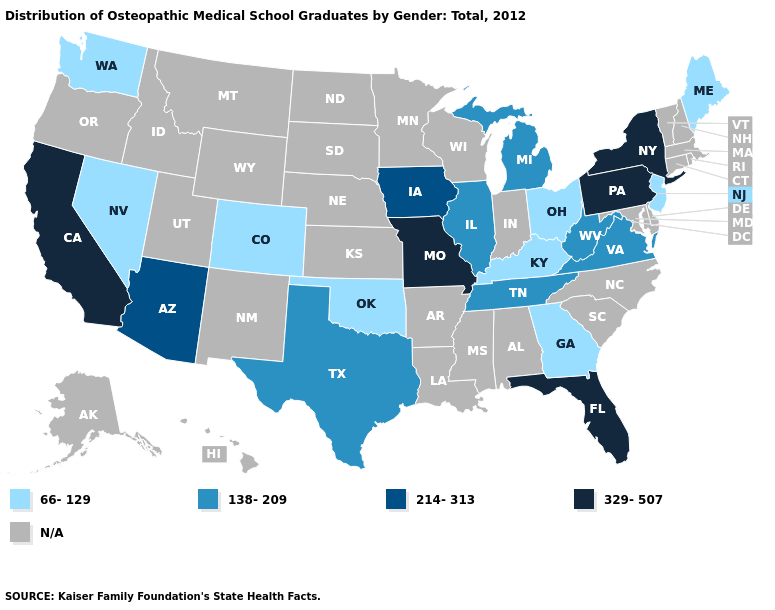What is the lowest value in the MidWest?
Be succinct. 66-129. What is the value of Mississippi?
Be succinct. N/A. Name the states that have a value in the range 214-313?
Keep it brief. Arizona, Iowa. What is the lowest value in the South?
Answer briefly. 66-129. Name the states that have a value in the range N/A?
Answer briefly. Alabama, Alaska, Arkansas, Connecticut, Delaware, Hawaii, Idaho, Indiana, Kansas, Louisiana, Maryland, Massachusetts, Minnesota, Mississippi, Montana, Nebraska, New Hampshire, New Mexico, North Carolina, North Dakota, Oregon, Rhode Island, South Carolina, South Dakota, Utah, Vermont, Wisconsin, Wyoming. What is the lowest value in states that border Florida?
Short answer required. 66-129. Name the states that have a value in the range N/A?
Short answer required. Alabama, Alaska, Arkansas, Connecticut, Delaware, Hawaii, Idaho, Indiana, Kansas, Louisiana, Maryland, Massachusetts, Minnesota, Mississippi, Montana, Nebraska, New Hampshire, New Mexico, North Carolina, North Dakota, Oregon, Rhode Island, South Carolina, South Dakota, Utah, Vermont, Wisconsin, Wyoming. Does California have the highest value in the West?
Write a very short answer. Yes. Does Florida have the lowest value in the South?
Write a very short answer. No. What is the value of Minnesota?
Write a very short answer. N/A. What is the highest value in the USA?
Give a very brief answer. 329-507. What is the value of Ohio?
Write a very short answer. 66-129. Does Iowa have the highest value in the USA?
Short answer required. No. 